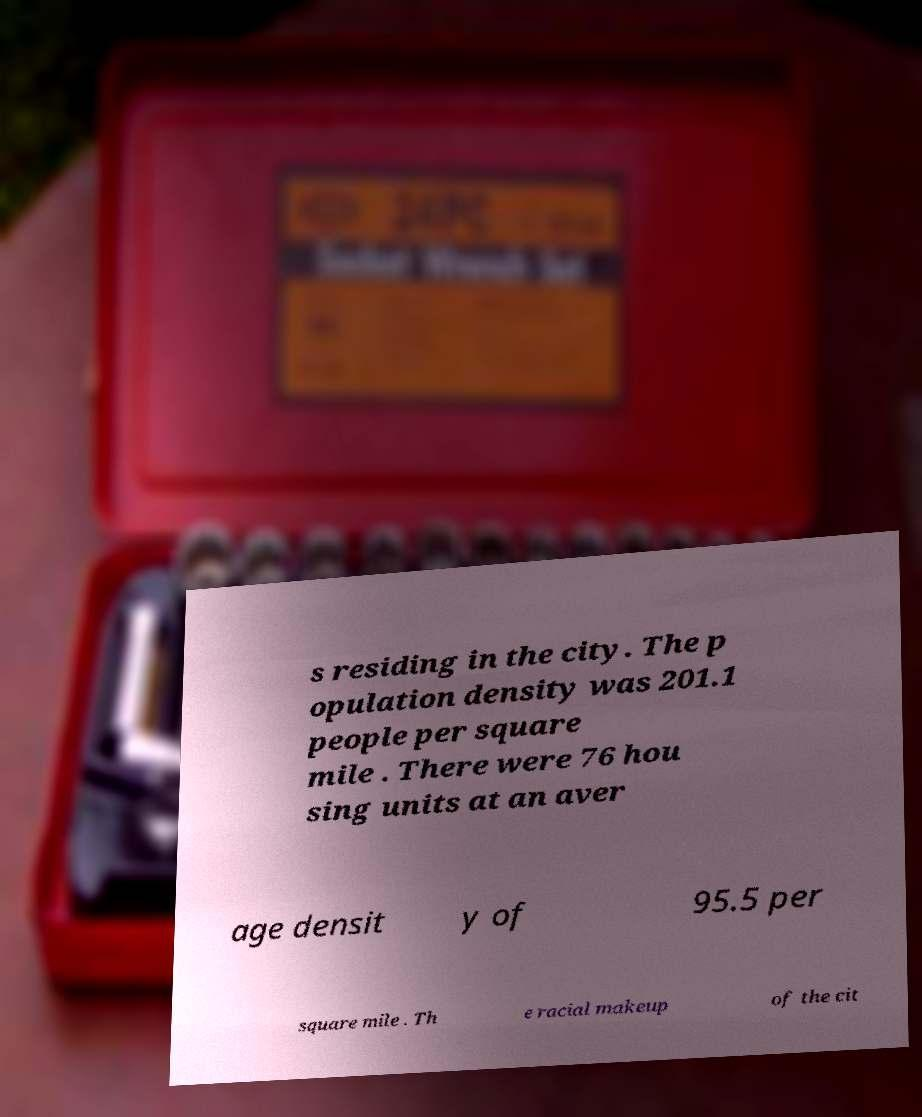What messages or text are displayed in this image? I need them in a readable, typed format. s residing in the city. The p opulation density was 201.1 people per square mile . There were 76 hou sing units at an aver age densit y of 95.5 per square mile . Th e racial makeup of the cit 